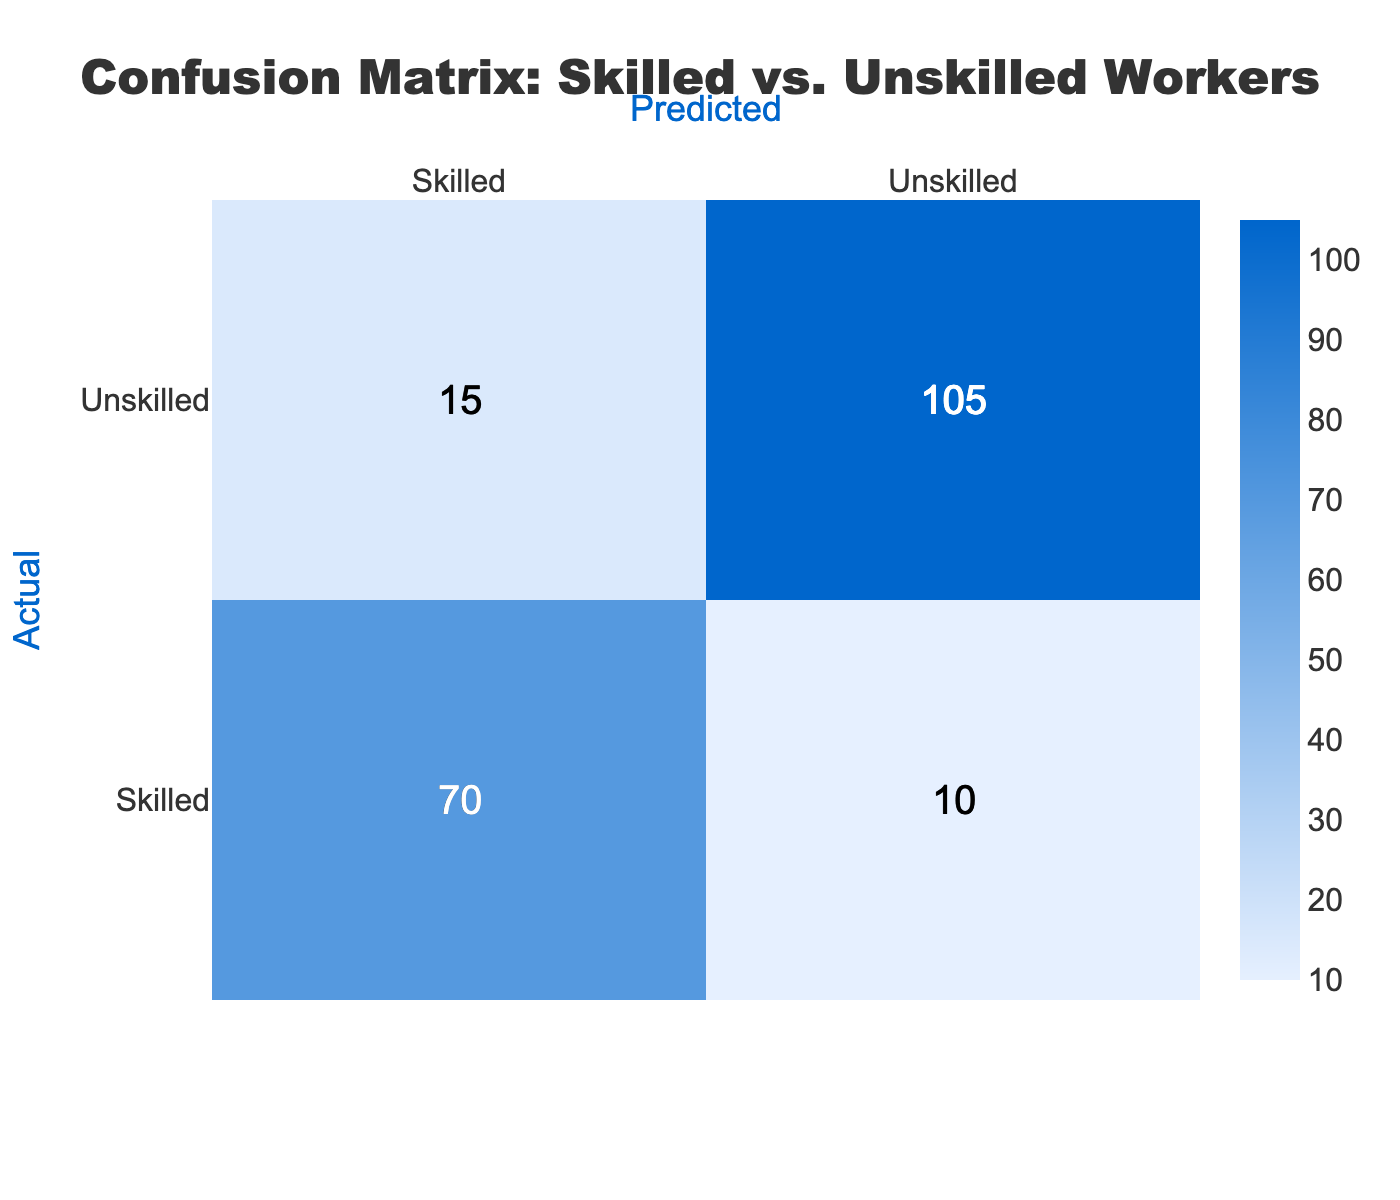What is the number of skilled workers classified as skilled? According to the table, the value in the intersection of "Skilled" row and "Skilled" column is 70. Thus, 70 skilled workers were correctly classified as skilled.
Answer: 70 What is the total number of unskilled workers? To find the total number of unskilled workers, we add the counts from the "Unskilled" row: Unskilled/Skilled (15) + Unskilled/Unskilled (105) = 15 + 105 = 120.
Answer: 120 Is it true that more skilled workers were classified as unskilled than unskilled workers classified as skilled? Looking at the table, skilled workers classified as unskilled are 10, while unskilled workers classified as skilled are 15. Therefore, it is not true since 15 (unskilled classified as skilled) is greater than 10.
Answer: No What is the accuracy of the classification? Accuracy can be found using the formula (true positives + true negatives) / total instances. Here, true positives (Skilled as Skilled) = 70, true negatives (Unskilled as Unskilled) = 105, total instances = 70 + 10 + 15 + 105 = 200. Thus, accuracy = (70 + 105) / 200 = 175 / 200 = 0.875.
Answer: 0.875 How many total workers were correctly classified? The total number of correctly classified workers consists of true positives (70 skilled classified as skilled) and true negatives (105 unskilled classified as unskilled). Thus, 70 + 105 = 175.
Answer: 175 What is the ratio of skilled workers classified correctly to those classified incorrectly? Skilled workers classified correctly (70) and incorrectly (10) gives a ratio of 70:10, which simplifies to 7:1.
Answer: 7:1 